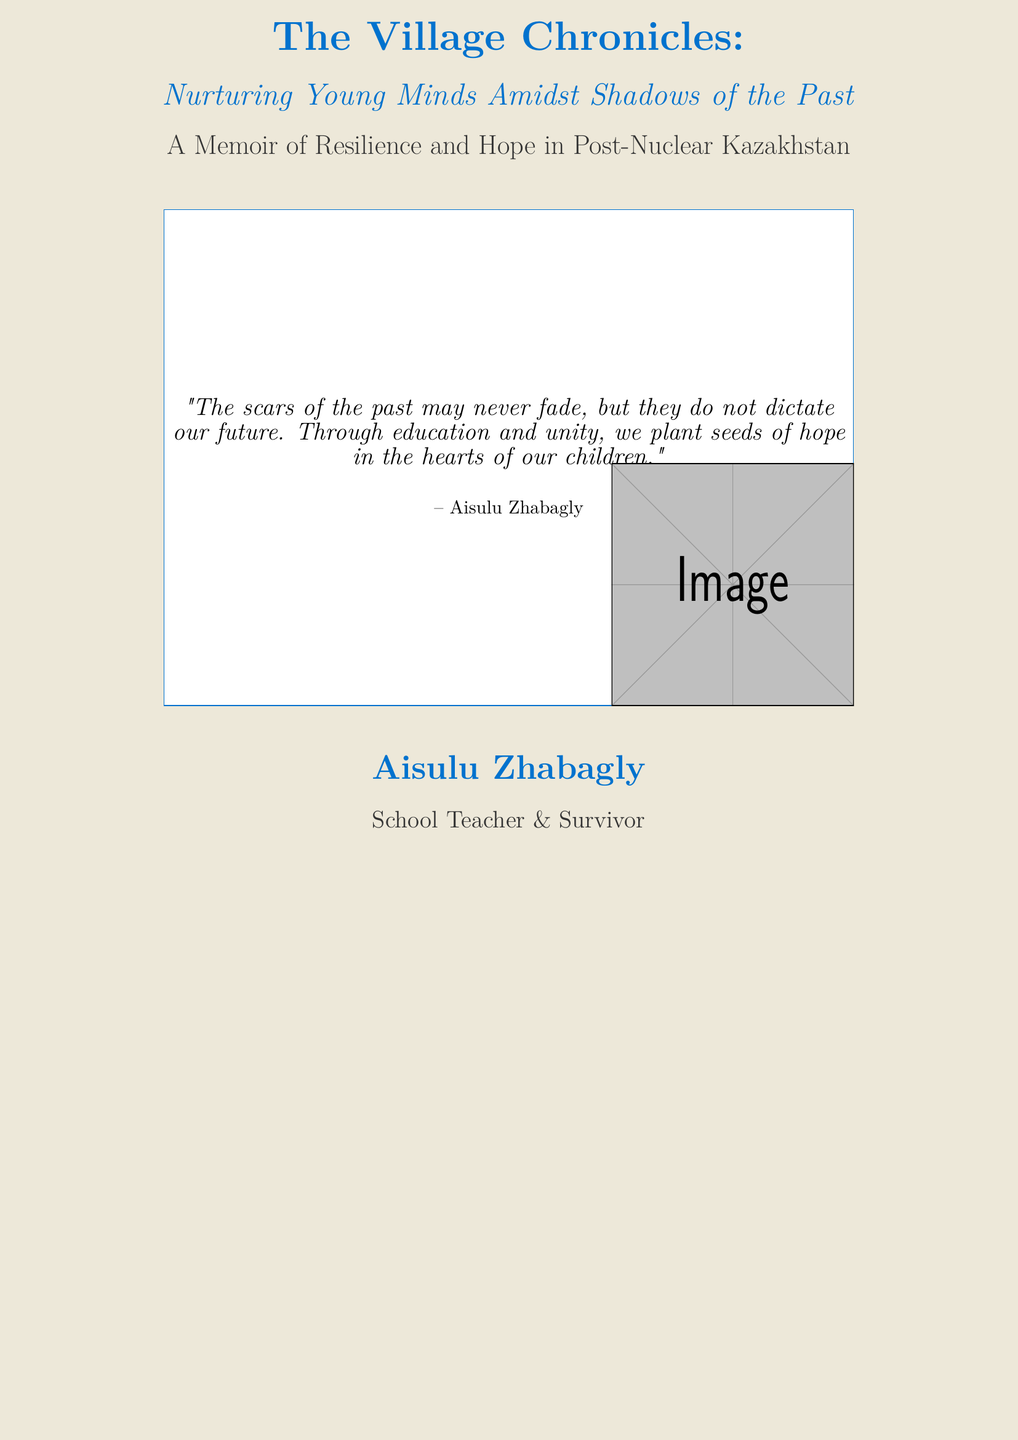What is the title of the book? The title is prominently displayed in large font on the cover.
Answer: The Village Chronicles Who is the author of the book? The author's name is featured near the bottom of the cover.
Answer: Aisulu Zhabagly What role does the author have? The cover indicates the author's profession below their name.
Answer: School Teacher What is the subtitle of the book? The subtitle describes the focus of the memoir and is located just below the title.
Answer: Nurturing Young Minds Amidst Shadows of the Past What is the main theme expressed in the quotation? The quote emphasizes a key message related to the author's experiences and beliefs.
Answer: Hope in the hearts of our children What kind of memoir is this book categorized as? The category of the memoir is clarified in the descriptive text.
Answer: Resilience and Hope What color is used for the author's name? The text color for the author’s name is specified on the cover for visual appeal.
Answer: Kazakh blue What visual element is included on the cover? The cover contains a specific type of graphic element that adds to its design.
Answer: An image What does the quote suggest about the past? The quote reflects the author’s perspective on the relationship between past experiences and the future.
Answer: Scars may never fade 